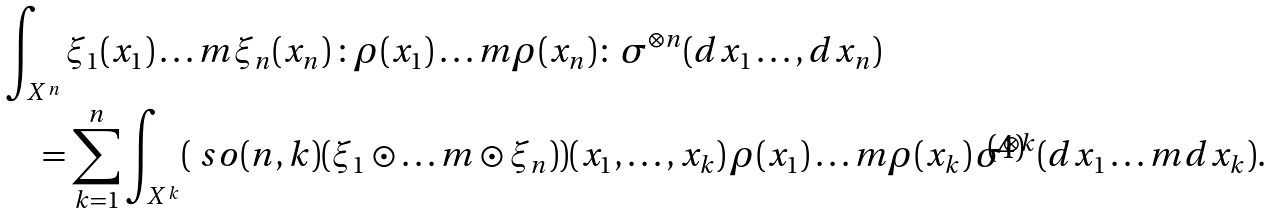<formula> <loc_0><loc_0><loc_500><loc_500>& \int _ { X ^ { n } } \xi _ { 1 } ( x _ { 1 } ) \dots m \xi _ { n } ( x _ { n } ) \, { \colon } \rho ( x _ { 1 } ) \dots m \rho ( x _ { n } ) { \colon } \, \sigma ^ { \otimes n } ( d x _ { 1 } \dots , d x _ { n } ) \\ & \quad = \sum _ { k = 1 } ^ { n } \int _ { X ^ { k } } ( \ s o ( n , k ) ( \xi _ { 1 } \odot \dots m \odot \xi _ { n } ) ) ( x _ { 1 } , \dots , x _ { k } ) \, \rho ( x _ { 1 } ) \dots m \rho ( x _ { k } ) \, \sigma ^ { \otimes k } ( d x _ { 1 } \dots m d x _ { k } ) .</formula> 